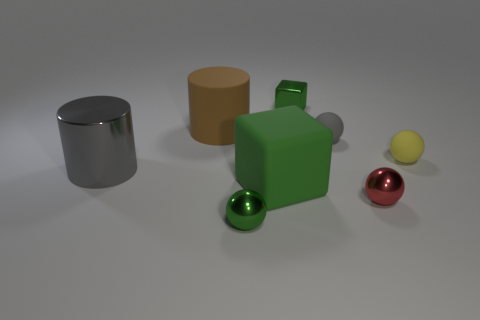Subtract all blue spheres. Subtract all blue cylinders. How many spheres are left? 4 Add 1 small yellow metallic balls. How many objects exist? 9 Subtract all cylinders. How many objects are left? 6 Add 5 large brown matte objects. How many large brown matte objects exist? 6 Subtract 0 cyan balls. How many objects are left? 8 Subtract all tiny green balls. Subtract all tiny green shiny blocks. How many objects are left? 6 Add 6 rubber balls. How many rubber balls are left? 8 